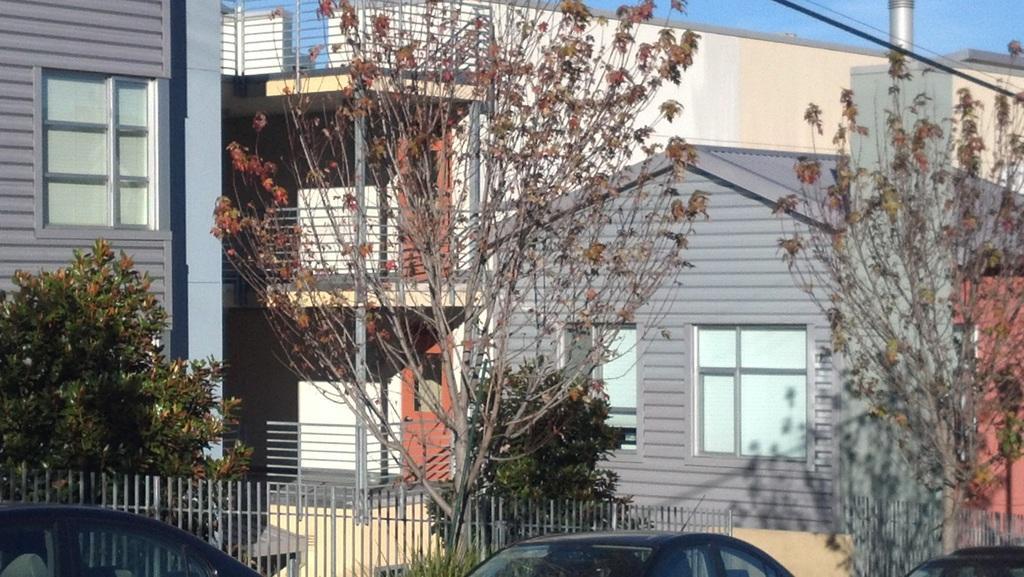Describe this image in one or two sentences. In the picture we can see a house building and beside it, we can see a house with window and glass in it and near to it, we can see some plants and around it we can see railing and behind the railing we can see some cars are parked and behind the buildings we can see a sky. 